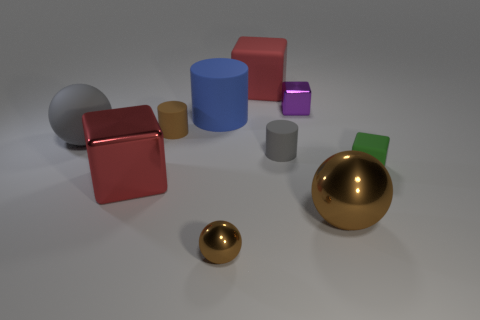There is a gray object that is in front of the matte ball; is it the same size as the green cube?
Provide a short and direct response. Yes. What number of other objects are the same material as the green object?
Offer a terse response. 5. Is the number of tiny purple objects on the right side of the green matte cube the same as the number of tiny brown shiny spheres that are behind the purple object?
Give a very brief answer. Yes. The large thing in front of the metallic cube to the left of the red block that is behind the tiny purple metal block is what color?
Provide a succinct answer. Brown. There is a red object that is right of the small brown cylinder; what shape is it?
Make the answer very short. Cube. The small green object that is the same material as the tiny brown cylinder is what shape?
Your answer should be compact. Cube. Is there any other thing that is the same shape as the large gray object?
Offer a terse response. Yes. There is a gray rubber sphere; how many brown metallic objects are left of it?
Your response must be concise. 0. Is the number of large blue things that are behind the small ball the same as the number of large brown rubber cylinders?
Your response must be concise. No. Is the material of the large blue cylinder the same as the tiny brown sphere?
Keep it short and to the point. No. 